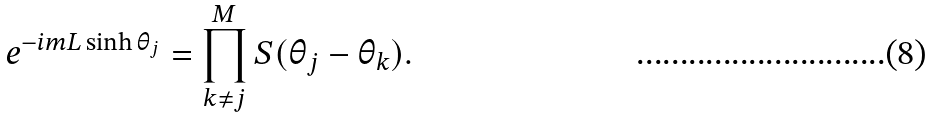<formula> <loc_0><loc_0><loc_500><loc_500>e ^ { - i m L \sinh \theta _ { j } } = \prod _ { k \neq j } ^ { M } S ( \theta _ { j } - \theta _ { k } ) .</formula> 